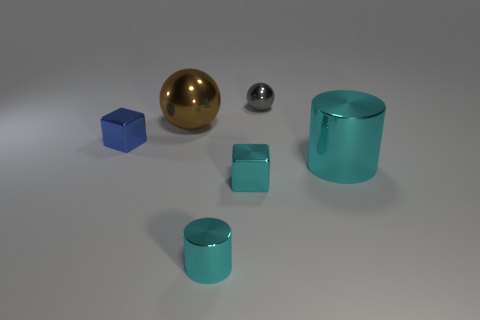Add 2 big brown metallic objects. How many objects exist? 8 Subtract 1 blocks. How many blocks are left? 1 Subtract all spheres. How many objects are left? 4 Add 4 large cyan objects. How many large cyan objects are left? 5 Add 3 large cyan cylinders. How many large cyan cylinders exist? 4 Subtract 1 cyan blocks. How many objects are left? 5 Subtract all cyan metal things. Subtract all green shiny balls. How many objects are left? 3 